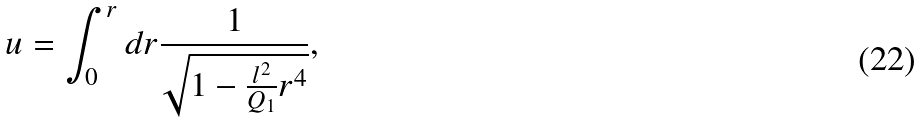<formula> <loc_0><loc_0><loc_500><loc_500>u = \int _ { 0 } ^ { r } d r \frac { 1 } { \sqrt { 1 - \frac { l ^ { 2 } } { Q _ { 1 } } r ^ { 4 } } } ,</formula> 